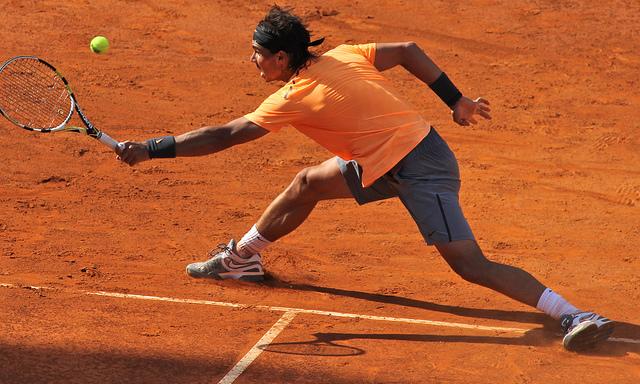Is the tennis ball above the racket?
Keep it brief. Yes. What surface are the courts?
Concise answer only. Dirt. This man is serving?
Quick response, please. No. 